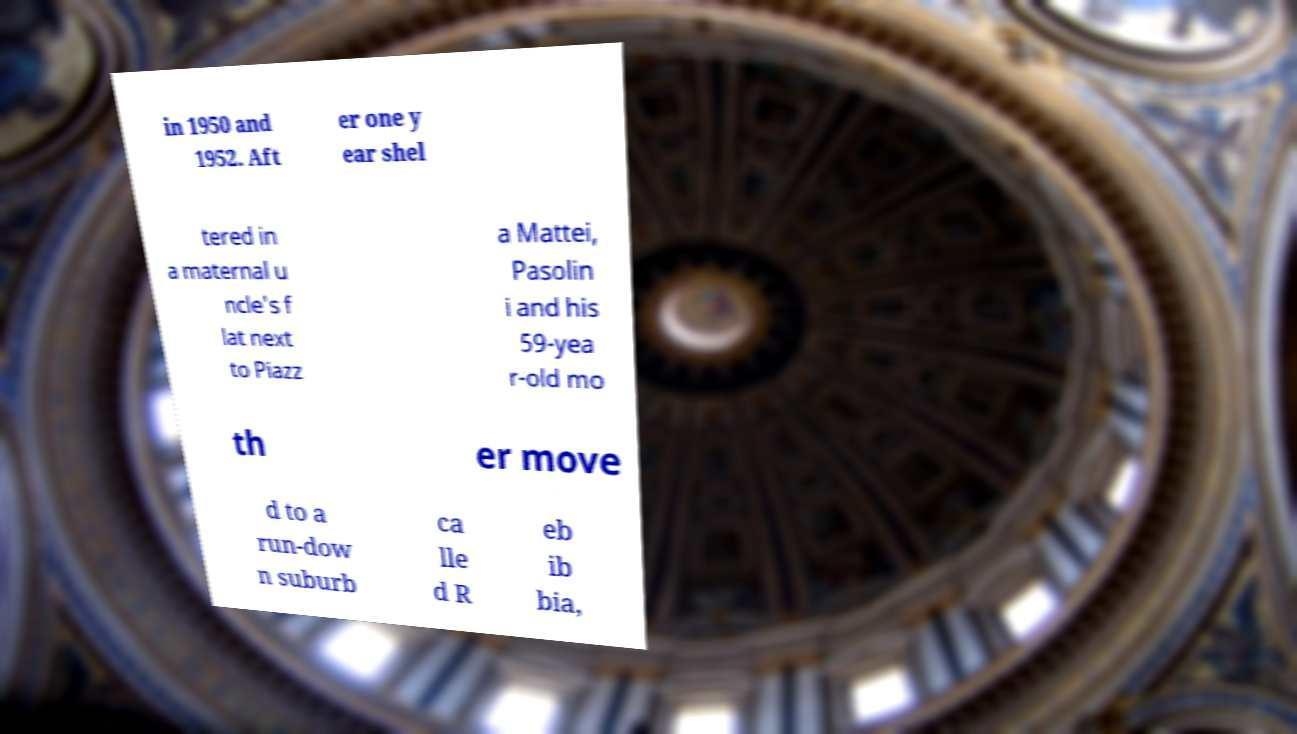Please identify and transcribe the text found in this image. in 1950 and 1952. Aft er one y ear shel tered in a maternal u ncle's f lat next to Piazz a Mattei, Pasolin i and his 59-yea r-old mo th er move d to a run-dow n suburb ca lle d R eb ib bia, 